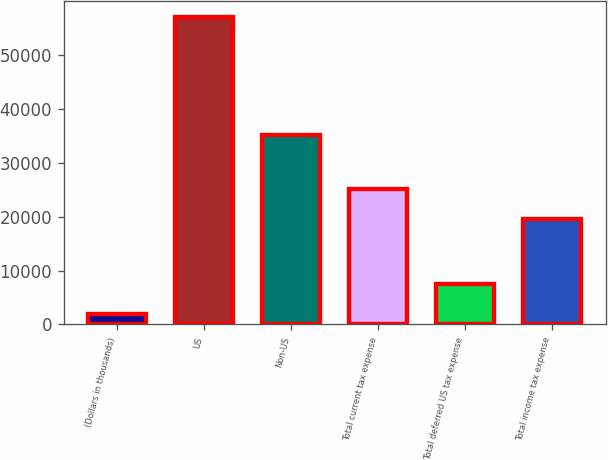<chart> <loc_0><loc_0><loc_500><loc_500><bar_chart><fcel>(Dollars in thousands)<fcel>US<fcel>Non-US<fcel>Total current tax expense<fcel>Total deferred US tax expense<fcel>Total income tax expense<nl><fcel>2010<fcel>57073<fcel>35056<fcel>25022.3<fcel>7516.3<fcel>19516<nl></chart> 